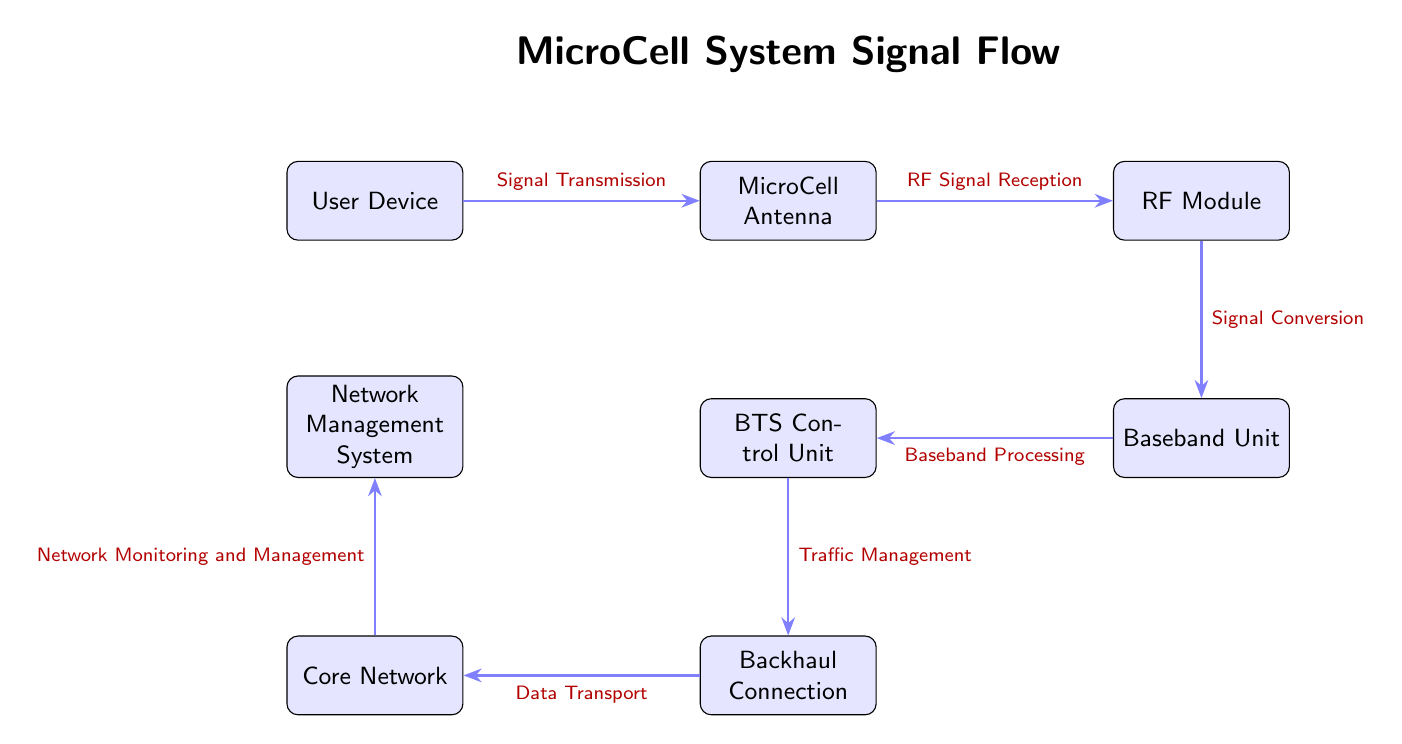What is the first node in the signal flow? The first node in the signal flow is the "User Device," which receives the signal from the user.
Answer: User Device What type of connection is shown between the Baseband Unit and the BTS Control Unit? The connection between the Baseband Unit and the BTS Control Unit is labeled "Baseband Processing," indicating that the baseband processes data before it reaches the control unit.
Answer: Baseband Processing How many total nodes are present in the diagram? Counting all the distinct nodes in the diagram, there are seven: User Device, MicroCell Antenna, RF Module, Baseband Unit, BTS Control Unit, Backhaul Connection, Core Network, and Network Management System.
Answer: Seven What action occurs between the RF Module and the Baseband Unit? The action between these two nodes is "Signal Conversion," which refers to the conversion of RF signals to baseband signals for processing.
Answer: Signal Conversion Which node is responsible for Traffic Management? The "BTS Control Unit" is identified as responsible for Traffic Management, controlling the signal traffic between the units and the backhaul connection.
Answer: BTS Control Unit What is the last node in the signal flow? The last node in the signal flow is the "Network Management System," which monitors and manages the overall network.
Answer: Network Management System What is the purpose of the Core Network node? The Core Network node is part of the data transport layer, facilitating communication between the MicroCell system and the outside world, specifically for data transport.
Answer: Data Transport How does the signal flow continue after the Backhaul Connection? After the Backhaul Connection, the signal flows to the Core Network, indicating that data is transported from the base station to the core network.
Answer: Core Network What does the arrow labeled "Network Monitoring and Management" connect? The arrow labeled "Network Monitoring and Management" connects the Core Network to the Network Management System, which is responsible for overseeing network performance.
Answer: Network Management System 